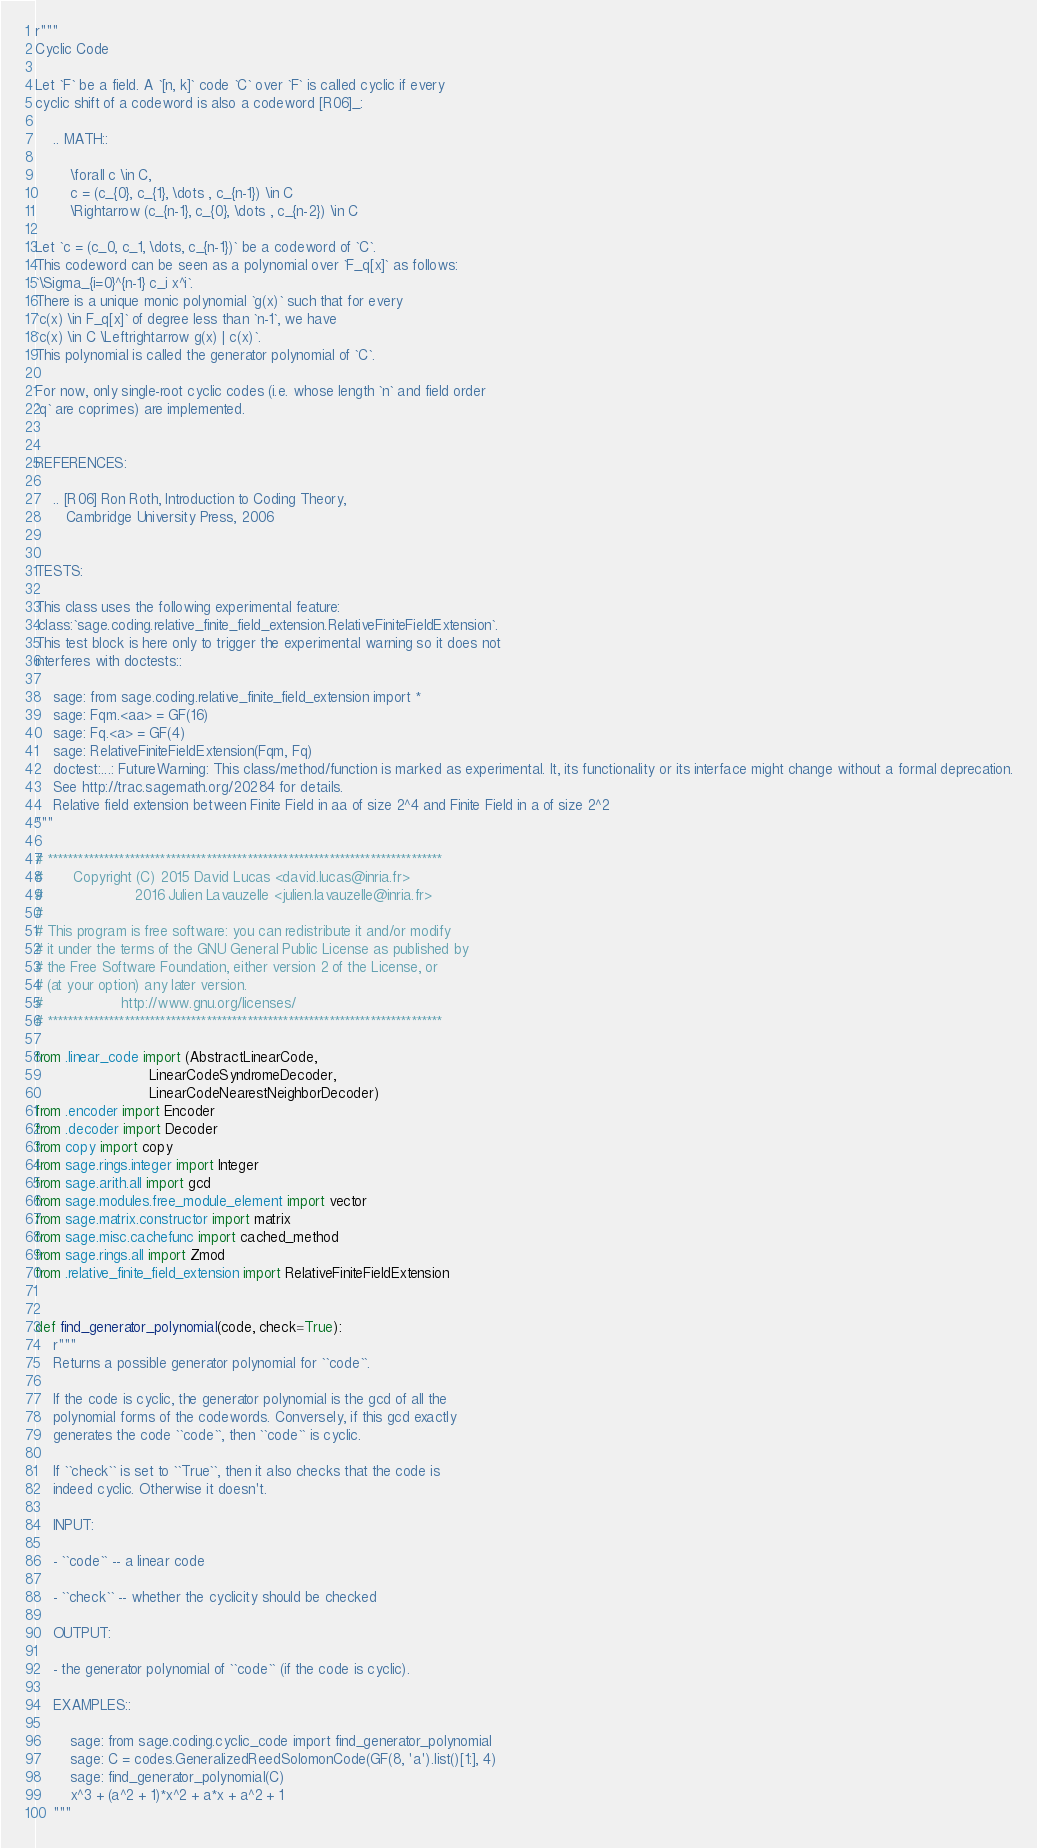<code> <loc_0><loc_0><loc_500><loc_500><_Python_>r"""
Cyclic Code

Let `F` be a field. A `[n, k]` code `C` over `F` is called cyclic if every
cyclic shift of a codeword is also a codeword [R06]_:

    .. MATH::

        \forall c \in C,
        c = (c_{0}, c_{1}, \dots , c_{n-1}) \in C
        \Rightarrow (c_{n-1}, c_{0}, \dots , c_{n-2}) \in C

Let `c = (c_0, c_1, \dots, c_{n-1})` be a codeword of `C`.
This codeword can be seen as a polynomial over `F_q[x]` as follows:
`\Sigma_{i=0}^{n-1} c_i x^i`.
There is a unique monic polynomial `g(x)` such that for every
`c(x) \in F_q[x]` of degree less than `n-1`, we have
`c(x) \in C \Leftrightarrow g(x) | c(x)`.
This polynomial is called the generator polynomial of `C`.

For now, only single-root cyclic codes (i.e. whose length `n` and field order
`q` are coprimes) are implemented.


REFERENCES:

    .. [R06] Ron Roth, Introduction to Coding Theory,
       Cambridge University Press, 2006


TESTS:

This class uses the following experimental feature:
:class:`sage.coding.relative_finite_field_extension.RelativeFiniteFieldExtension`.
This test block is here only to trigger the experimental warning so it does not
interferes with doctests::

    sage: from sage.coding.relative_finite_field_extension import *
    sage: Fqm.<aa> = GF(16)
    sage: Fq.<a> = GF(4)
    sage: RelativeFiniteFieldExtension(Fqm, Fq)
    doctest:...: FutureWarning: This class/method/function is marked as experimental. It, its functionality or its interface might change without a formal deprecation.
    See http://trac.sagemath.org/20284 for details.
    Relative field extension between Finite Field in aa of size 2^4 and Finite Field in a of size 2^2
"""

# *****************************************************************************
#       Copyright (C) 2015 David Lucas <david.lucas@inria.fr>
#                     2016 Julien Lavauzelle <julien.lavauzelle@inria.fr>
#
# This program is free software: you can redistribute it and/or modify
# it under the terms of the GNU General Public License as published by
# the Free Software Foundation, either version 2 of the License, or
# (at your option) any later version.
#                  http://www.gnu.org/licenses/
# *****************************************************************************

from .linear_code import (AbstractLinearCode,
                          LinearCodeSyndromeDecoder,
                          LinearCodeNearestNeighborDecoder)
from .encoder import Encoder
from .decoder import Decoder
from copy import copy
from sage.rings.integer import Integer
from sage.arith.all import gcd
from sage.modules.free_module_element import vector
from sage.matrix.constructor import matrix
from sage.misc.cachefunc import cached_method
from sage.rings.all import Zmod
from .relative_finite_field_extension import RelativeFiniteFieldExtension


def find_generator_polynomial(code, check=True):
    r"""
    Returns a possible generator polynomial for ``code``.

    If the code is cyclic, the generator polynomial is the gcd of all the
    polynomial forms of the codewords. Conversely, if this gcd exactly
    generates the code ``code``, then ``code`` is cyclic.

    If ``check`` is set to ``True``, then it also checks that the code is
    indeed cyclic. Otherwise it doesn't.

    INPUT:

    - ``code`` -- a linear code

    - ``check`` -- whether the cyclicity should be checked

    OUTPUT:

    - the generator polynomial of ``code`` (if the code is cyclic).

    EXAMPLES::

        sage: from sage.coding.cyclic_code import find_generator_polynomial
        sage: C = codes.GeneralizedReedSolomonCode(GF(8, 'a').list()[1:], 4)
        sage: find_generator_polynomial(C)
        x^3 + (a^2 + 1)*x^2 + a*x + a^2 + 1
    """</code> 